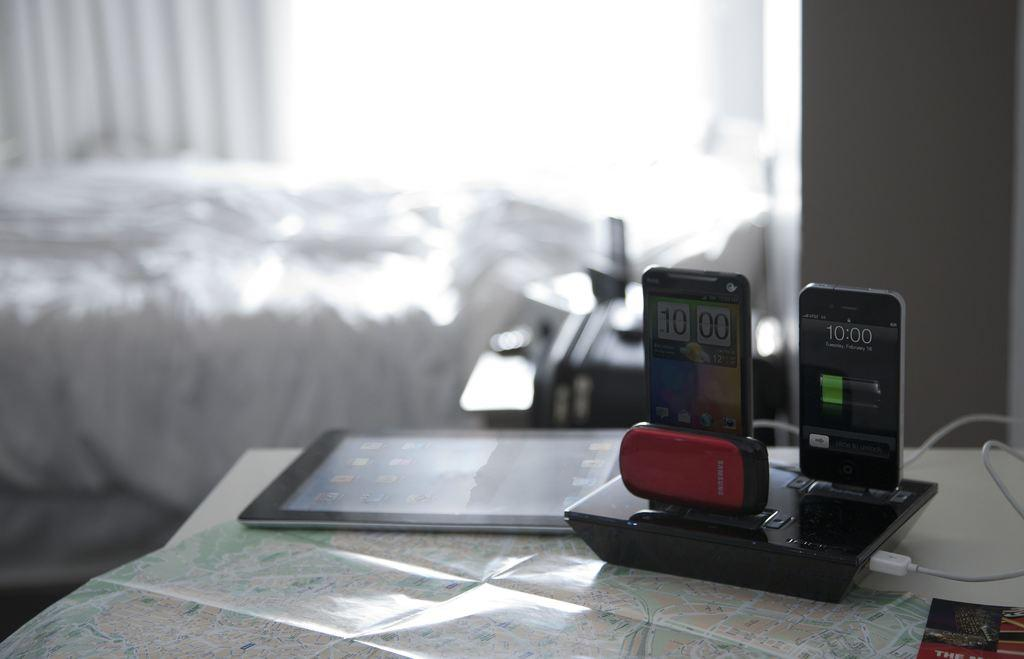What is the main piece of furniture in the image? There is a table in the image. What is placed on the table? A map, a tablet, and a charging port for mobiles are present on the table. What can be seen in the background of the image? There is a wall in the background of the image. What type of rock is being used as a paperweight for the map in the image? There is no rock present in the image; the map is not depicted as having a paperweight. 